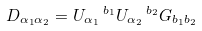Convert formula to latex. <formula><loc_0><loc_0><loc_500><loc_500>D _ { \alpha _ { 1 } \alpha _ { 2 } } = U _ { \alpha _ { 1 } } \, ^ { b _ { 1 } } U _ { \alpha _ { 2 } } \, ^ { b _ { 2 } } G _ { b _ { 1 } b _ { 2 } }</formula> 